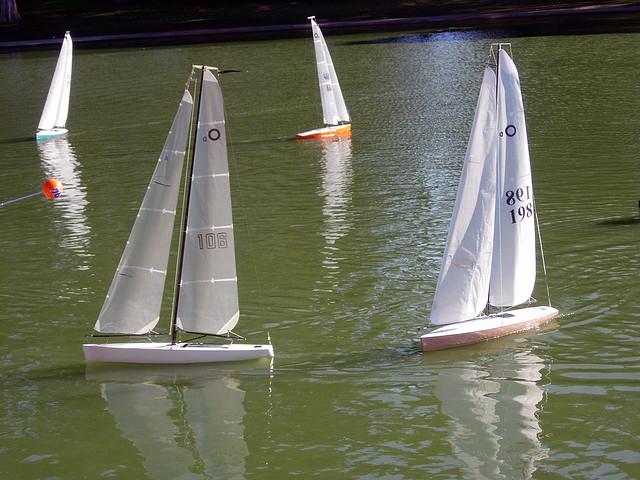How many sailboats are in this scene?
Keep it brief. 4. Where are the sailboats?
Short answer required. In water. Are the boats toys?
Quick response, please. Yes. 